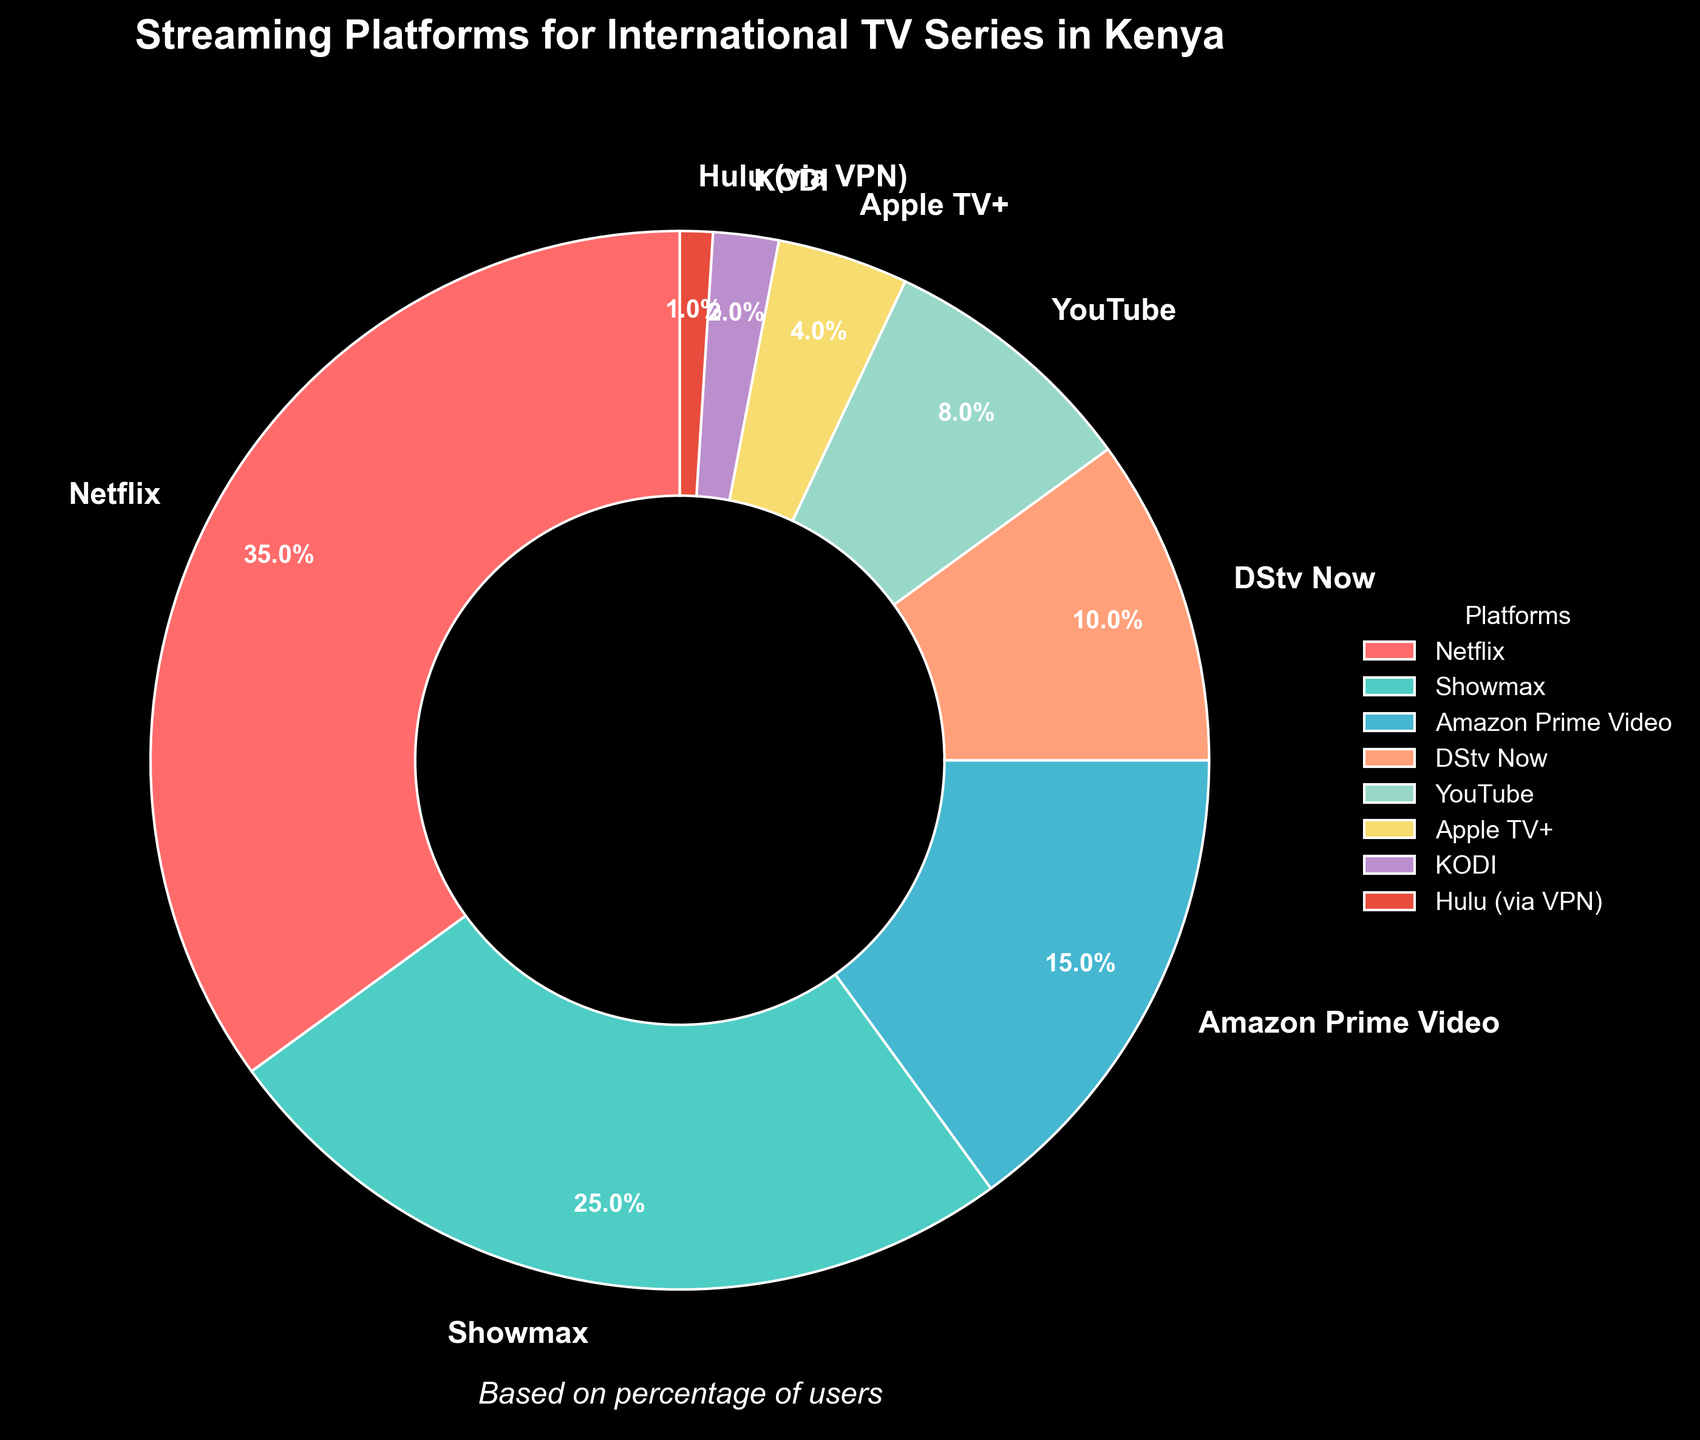Which platform has the largest percentage of users? The largest segment in the pie chart is for Netflix. By looking at the segments in the pie chart, it is evident that Netflix has the largest share.
Answer: Netflix Which two platforms have the smallest pieces on the chart? The smallest slices in the pie chart are for Hulu (via VPN) and KODI. This can be observed from the respective sizes of the slices.
Answer: Hulu (via VPN) and KODI What is the combined percentage of users for Amazon Prime Video and YouTube? Amazon Prime Video has 15% and YouTube has 8%. Adding these percentages together gives 15% + 8% = 23%.
Answer: 23% How much bigger is Netflix’s percentage compared to Showmax? Netflix has 35% and Showmax has 25%. The difference between them is 35% - 25% = 10%.
Answer: 10% Which two platforms together make up more than half of the user base? The platforms and their percentages are Netflix (35%) and Showmax (25%). Together, their combined percentage is 35% + 25% = 60%, which is more than half (50%) of the total.
Answer: Netflix and Showmax What percentage of users do not use Netflix, Showmax, or Amazon Prime Video? The percentages for Netflix, Showmax, and Amazon Prime Video are 35%, 25%, and 15%, respectively. Adding these up, we get 35% + 25% + 15% = 75%. Therefore, the percentage of users who do not use these three platforms is 100% - 75% = 25%.
Answer: 25% Which platform has a larger share: DStv Now or Apple TV+? From the pie chart, DStv Now has 10% and Apple TV+ has 4%. Therefore, DStv Now has a larger share.
Answer: DStv Now Rank the platforms from most used to least used. Observing the pie chart, the platforms rank as follows: 1. Netflix (35%), 2. Showmax (25%), 3. Amazon Prime Video (15%), 4. DStv Now (10%), 5. YouTube (8%), 6. Apple TV+ (4%), 7. KODI (2%), 8. Hulu (via VPN) (1%).
Answer: Netflix, Showmax, Amazon Prime Video, DStv Now, YouTube, Apple TV+, KODI, Hulu (via VPN) What percentage more users use Showmax compared to YouTube? Showmax has 25% and YouTube has 8%. The percentage more is calculated by (25% - 8%) / 8% * 100% = 212.5%.
Answer: 212.5% 